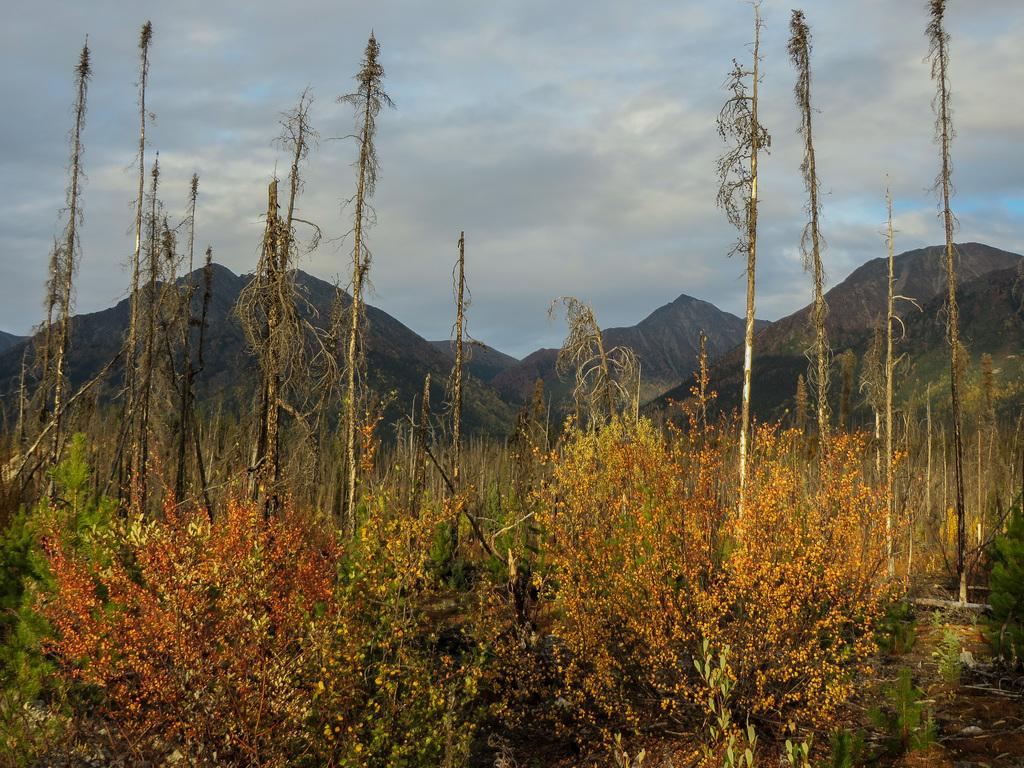What type of vegetation can be seen in the image? There are trees and plants in the image. What is visible in the background of the image? There are hills and sky visible in the background of the image. What can be seen in the sky? There are clouds in the sky. What type of fuel is being used by the question in the image? There is no question present in the image, and therefore no fuel can be associated with it. 